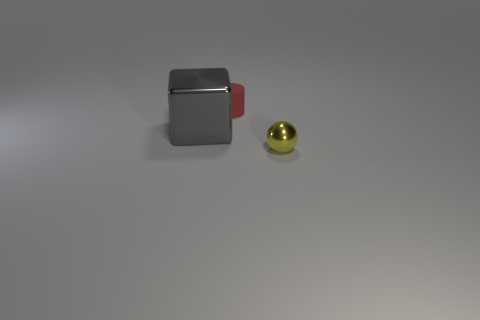Is the color of the rubber cylinder the same as the big object?
Give a very brief answer. No. How many objects are either tiny rubber things or things that are on the right side of the big gray object?
Provide a succinct answer. 2. How big is the object in front of the metal object behind the small object that is in front of the shiny cube?
Provide a succinct answer. Small. There is a ball that is the same size as the red cylinder; what is its material?
Your response must be concise. Metal. Is there a blue thing of the same size as the yellow shiny object?
Offer a terse response. No. There is a metallic thing that is to the left of the yellow shiny sphere; is its size the same as the yellow shiny ball?
Your response must be concise. No. What shape is the object that is both on the right side of the metallic cube and in front of the red cylinder?
Provide a short and direct response. Sphere. Is the number of large gray objects that are to the right of the tiny yellow metallic object greater than the number of tiny brown shiny cylinders?
Offer a very short reply. No. What is the size of the ball that is the same material as the big gray block?
Provide a short and direct response. Small. Does the tiny thing that is behind the yellow metal thing have the same color as the big metal block?
Make the answer very short. No. 